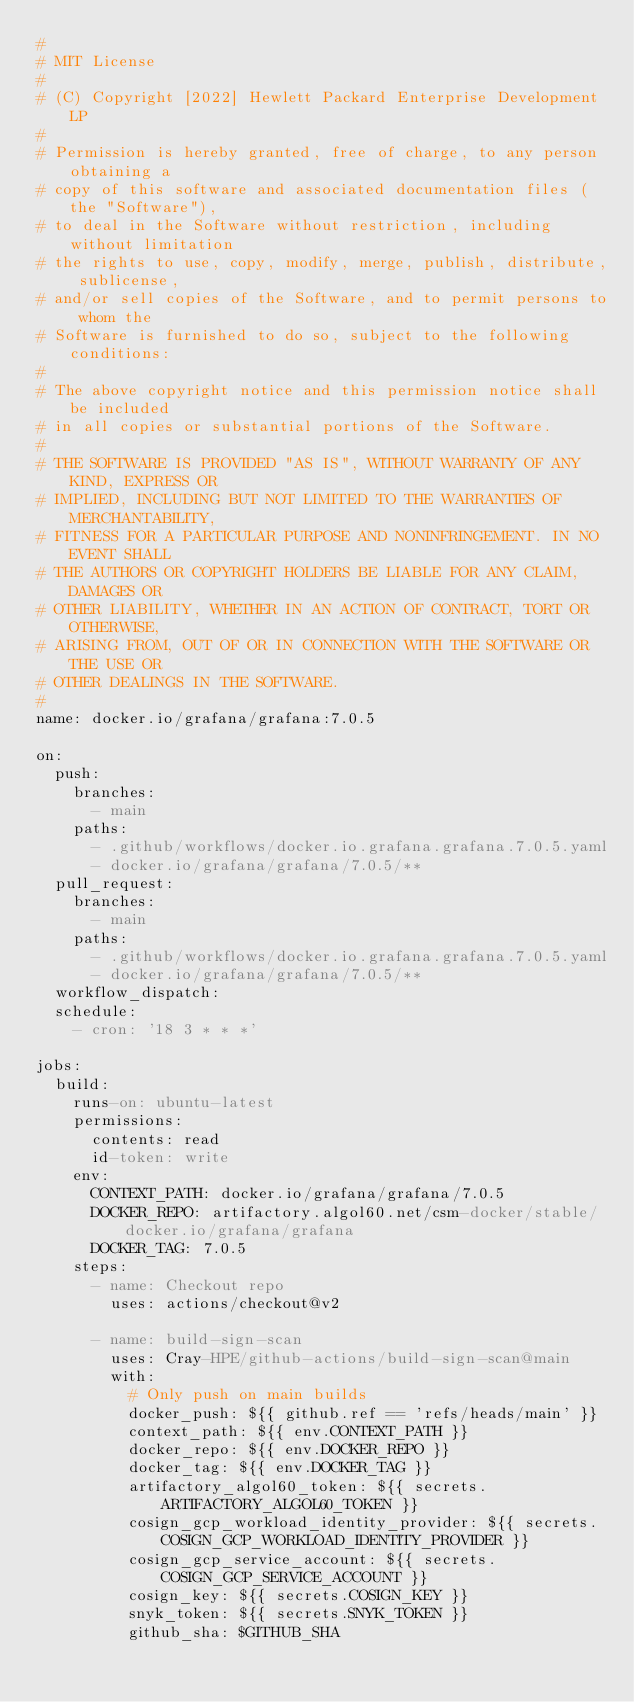Convert code to text. <code><loc_0><loc_0><loc_500><loc_500><_YAML_>#
# MIT License
#
# (C) Copyright [2022] Hewlett Packard Enterprise Development LP
#
# Permission is hereby granted, free of charge, to any person obtaining a
# copy of this software and associated documentation files (the "Software"),
# to deal in the Software without restriction, including without limitation
# the rights to use, copy, modify, merge, publish, distribute, sublicense,
# and/or sell copies of the Software, and to permit persons to whom the
# Software is furnished to do so, subject to the following conditions:
#
# The above copyright notice and this permission notice shall be included
# in all copies or substantial portions of the Software.
#
# THE SOFTWARE IS PROVIDED "AS IS", WITHOUT WARRANTY OF ANY KIND, EXPRESS OR
# IMPLIED, INCLUDING BUT NOT LIMITED TO THE WARRANTIES OF MERCHANTABILITY,
# FITNESS FOR A PARTICULAR PURPOSE AND NONINFRINGEMENT. IN NO EVENT SHALL
# THE AUTHORS OR COPYRIGHT HOLDERS BE LIABLE FOR ANY CLAIM, DAMAGES OR
# OTHER LIABILITY, WHETHER IN AN ACTION OF CONTRACT, TORT OR OTHERWISE,
# ARISING FROM, OUT OF OR IN CONNECTION WITH THE SOFTWARE OR THE USE OR
# OTHER DEALINGS IN THE SOFTWARE.
#
name: docker.io/grafana/grafana:7.0.5

on:
  push:
    branches:
      - main
    paths:
      - .github/workflows/docker.io.grafana.grafana.7.0.5.yaml
      - docker.io/grafana/grafana/7.0.5/**
  pull_request:
    branches:
      - main
    paths:
      - .github/workflows/docker.io.grafana.grafana.7.0.5.yaml
      - docker.io/grafana/grafana/7.0.5/**
  workflow_dispatch:
  schedule:
    - cron: '18 3 * * *'

jobs:
  build:
    runs-on: ubuntu-latest
    permissions:
      contents: read
      id-token: write
    env:
      CONTEXT_PATH: docker.io/grafana/grafana/7.0.5
      DOCKER_REPO: artifactory.algol60.net/csm-docker/stable/docker.io/grafana/grafana
      DOCKER_TAG: 7.0.5
    steps:
      - name: Checkout repo
        uses: actions/checkout@v2

      - name: build-sign-scan
        uses: Cray-HPE/github-actions/build-sign-scan@main
        with:
          # Only push on main builds
          docker_push: ${{ github.ref == 'refs/heads/main' }}
          context_path: ${{ env.CONTEXT_PATH }}
          docker_repo: ${{ env.DOCKER_REPO }}
          docker_tag: ${{ env.DOCKER_TAG }}
          artifactory_algol60_token: ${{ secrets.ARTIFACTORY_ALGOL60_TOKEN }}
          cosign_gcp_workload_identity_provider: ${{ secrets.COSIGN_GCP_WORKLOAD_IDENTITY_PROVIDER }}
          cosign_gcp_service_account: ${{ secrets.COSIGN_GCP_SERVICE_ACCOUNT }}
          cosign_key: ${{ secrets.COSIGN_KEY }}
          snyk_token: ${{ secrets.SNYK_TOKEN }}
          github_sha: $GITHUB_SHA
</code> 